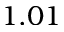Convert formula to latex. <formula><loc_0><loc_0><loc_500><loc_500>1 . 0 1</formula> 